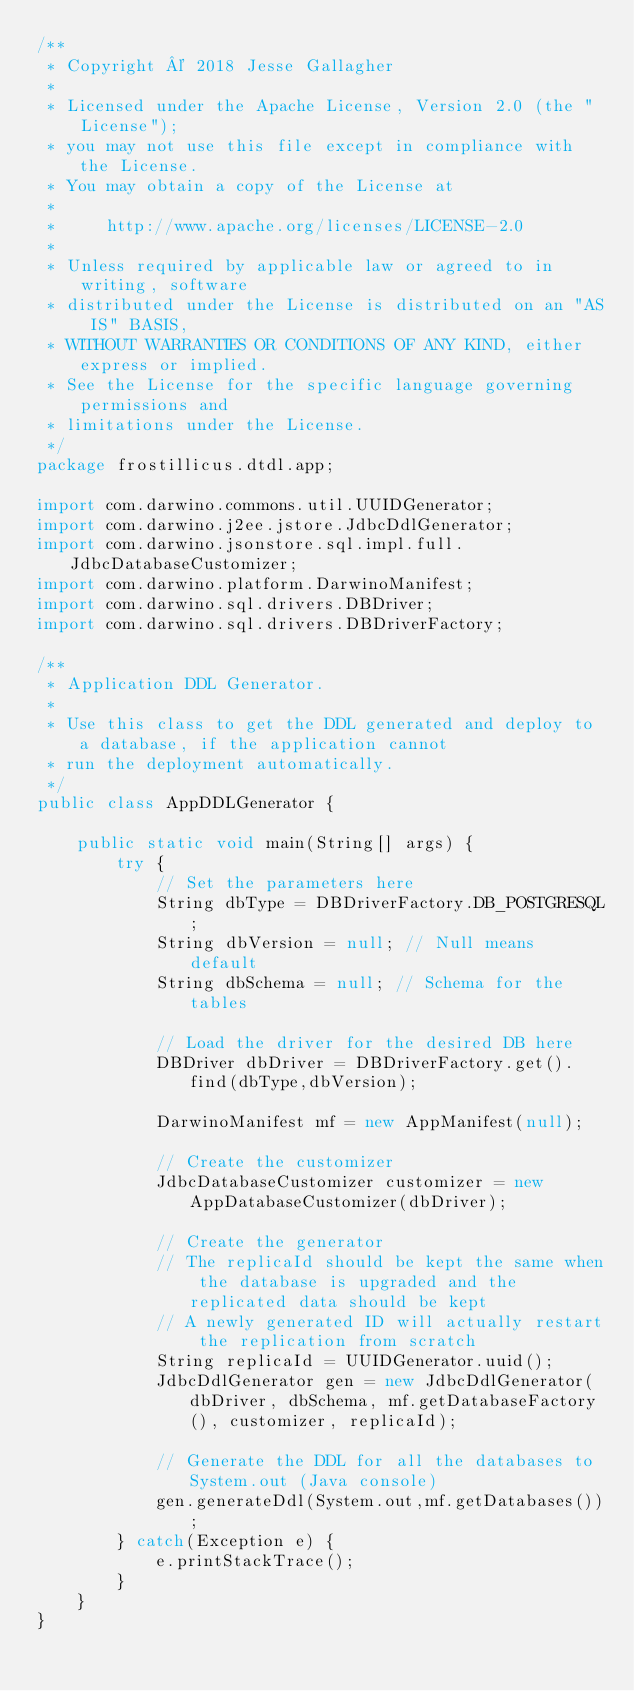<code> <loc_0><loc_0><loc_500><loc_500><_Java_>/**
 * Copyright © 2018 Jesse Gallagher
 *
 * Licensed under the Apache License, Version 2.0 (the "License");
 * you may not use this file except in compliance with the License.
 * You may obtain a copy of the License at
 *
 *     http://www.apache.org/licenses/LICENSE-2.0
 *
 * Unless required by applicable law or agreed to in writing, software
 * distributed under the License is distributed on an "AS IS" BASIS,
 * WITHOUT WARRANTIES OR CONDITIONS OF ANY KIND, either express or implied.
 * See the License for the specific language governing permissions and
 * limitations under the License.
 */
package frostillicus.dtdl.app;

import com.darwino.commons.util.UUIDGenerator;
import com.darwino.j2ee.jstore.JdbcDdlGenerator;
import com.darwino.jsonstore.sql.impl.full.JdbcDatabaseCustomizer;
import com.darwino.platform.DarwinoManifest;
import com.darwino.sql.drivers.DBDriver;
import com.darwino.sql.drivers.DBDriverFactory;

/**
 * Application DDL Generator.
 * 
 * Use this class to get the DDL generated and deploy to a database, if the application cannot
 * run the deployment automatically.
 */
public class AppDDLGenerator {
	
	public static void main(String[] args) {
		try {
			// Set the parameters here
			String dbType = DBDriverFactory.DB_POSTGRESQL;
			String dbVersion = null; // Null means default
			String dbSchema = null; // Schema for the tables
			
			// Load the driver for the desired DB here
			DBDriver dbDriver = DBDriverFactory.get().find(dbType,dbVersion);

			DarwinoManifest mf = new AppManifest(null);
			
			// Create the customizer
			JdbcDatabaseCustomizer customizer = new AppDatabaseCustomizer(dbDriver);
			
			// Create the generator
			// The replicaId should be kept the same when the database is upgraded and the replicated data should be kept
			// A newly generated ID will actually restart the replication from scratch
			String replicaId = UUIDGenerator.uuid();
			JdbcDdlGenerator gen = new JdbcDdlGenerator(dbDriver, dbSchema, mf.getDatabaseFactory(), customizer, replicaId);

			// Generate the DDL for all the databases to System.out (Java console)
			gen.generateDdl(System.out,mf.getDatabases());
		} catch(Exception e) {
			e.printStackTrace();
		}
	}
}
</code> 